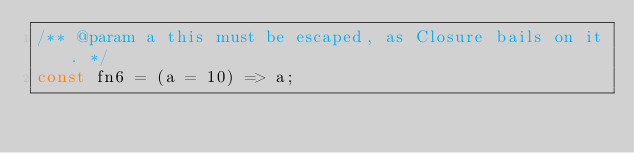<code> <loc_0><loc_0><loc_500><loc_500><_TypeScript_>/** @param a this must be escaped, as Closure bails on it. */
const fn6 = (a = 10) => a;
</code> 